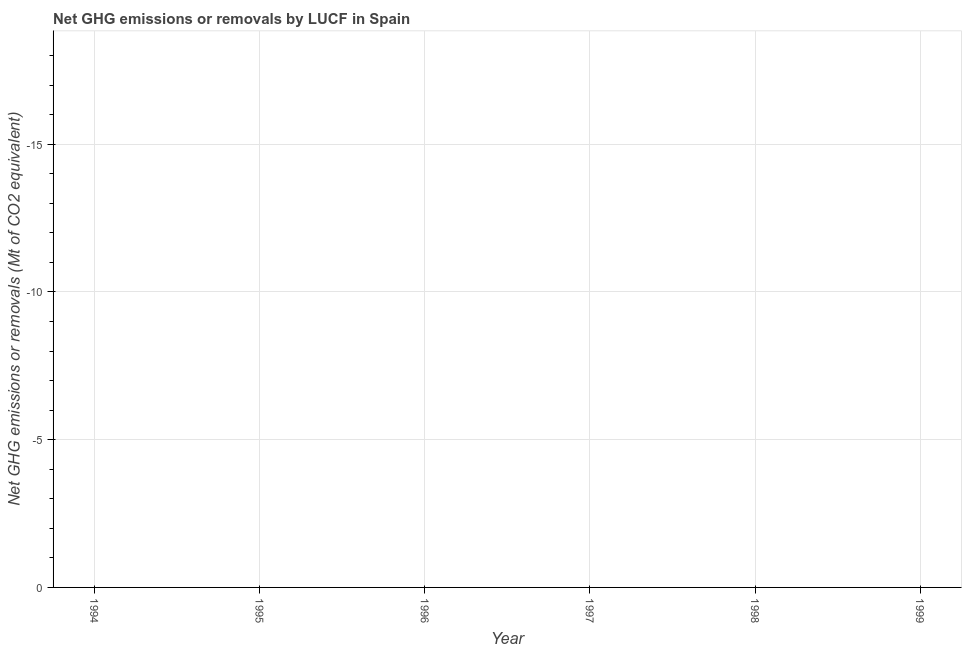Across all years, what is the minimum ghg net emissions or removals?
Offer a terse response. 0. What is the sum of the ghg net emissions or removals?
Give a very brief answer. 0. In how many years, is the ghg net emissions or removals greater than -18 Mt?
Provide a succinct answer. 0. How many years are there in the graph?
Provide a succinct answer. 6. What is the difference between two consecutive major ticks on the Y-axis?
Provide a succinct answer. 5. Are the values on the major ticks of Y-axis written in scientific E-notation?
Provide a short and direct response. No. Does the graph contain grids?
Your answer should be very brief. Yes. What is the title of the graph?
Ensure brevity in your answer.  Net GHG emissions or removals by LUCF in Spain. What is the label or title of the Y-axis?
Keep it short and to the point. Net GHG emissions or removals (Mt of CO2 equivalent). What is the Net GHG emissions or removals (Mt of CO2 equivalent) of 1995?
Provide a succinct answer. 0. What is the Net GHG emissions or removals (Mt of CO2 equivalent) in 1996?
Your answer should be very brief. 0. What is the Net GHG emissions or removals (Mt of CO2 equivalent) in 1997?
Offer a terse response. 0. What is the Net GHG emissions or removals (Mt of CO2 equivalent) in 1998?
Provide a succinct answer. 0. 